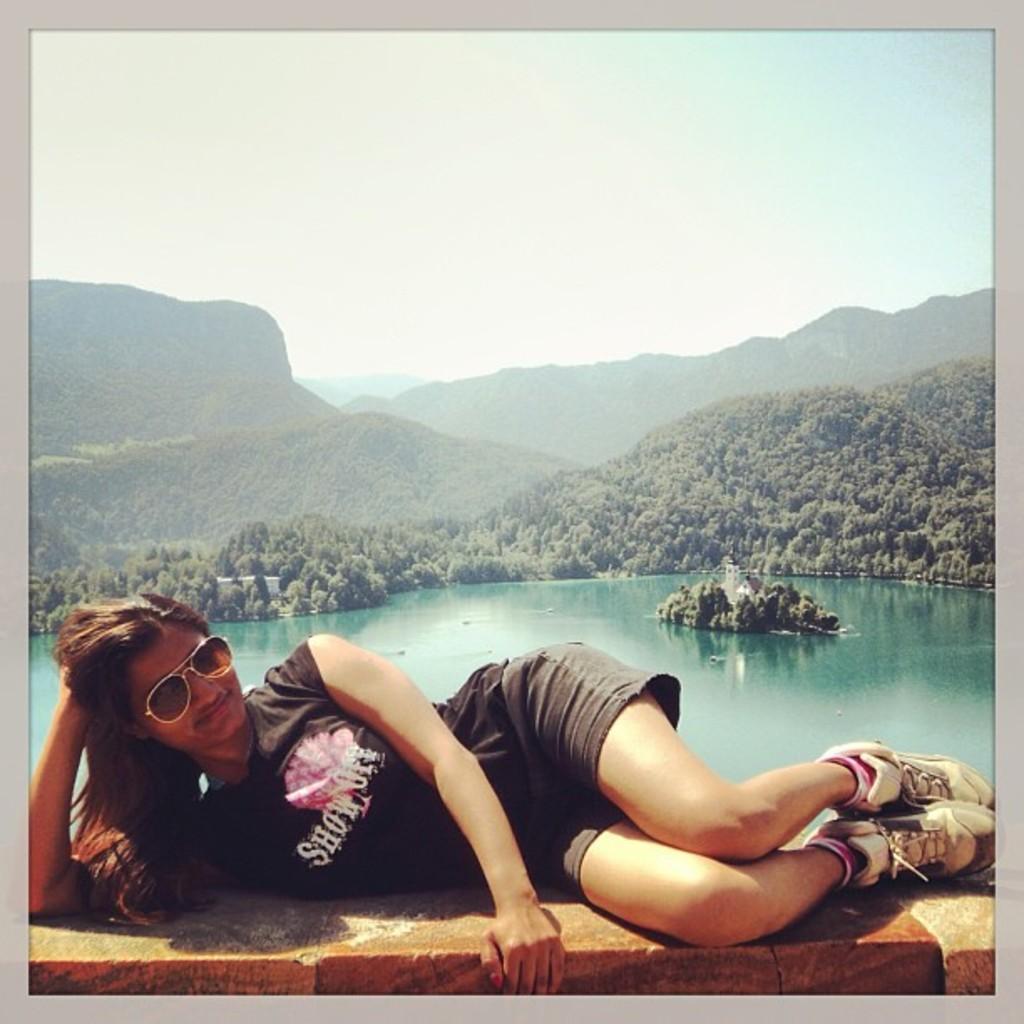Describe this image in one or two sentences. In this image there is a woman lying on the wall. She is smiling. She is wearing spectacles. Behind her there is the water. In the background there are mountains. There are trees on the mountains. At the top there is the sky. 